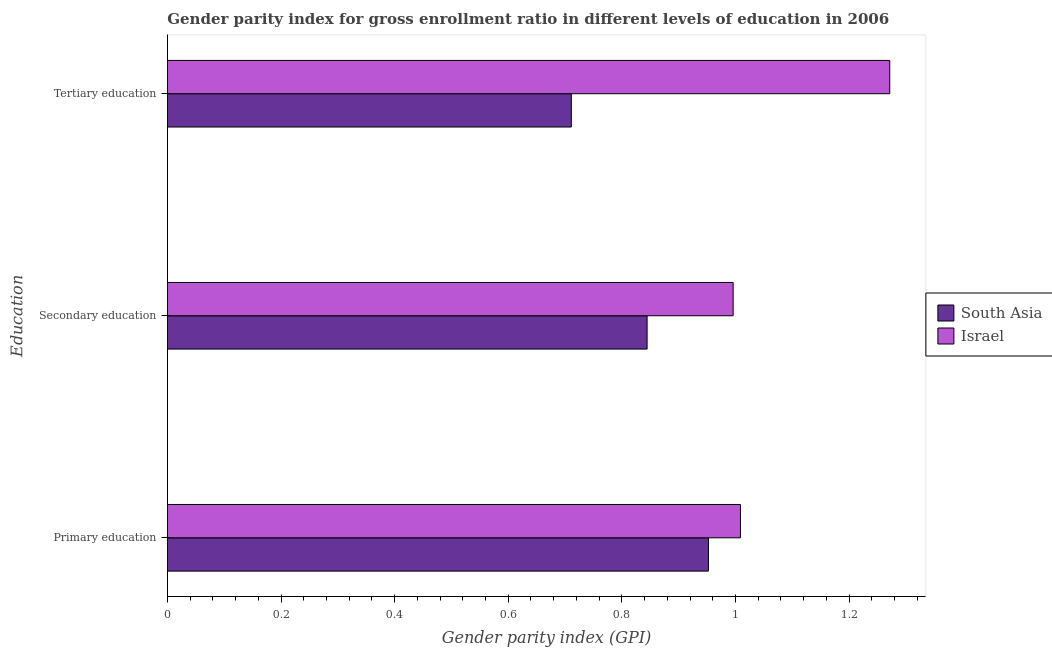How many groups of bars are there?
Your response must be concise. 3. What is the label of the 1st group of bars from the top?
Provide a short and direct response. Tertiary education. What is the gender parity index in secondary education in Israel?
Give a very brief answer. 1. Across all countries, what is the maximum gender parity index in tertiary education?
Keep it short and to the point. 1.27. Across all countries, what is the minimum gender parity index in secondary education?
Ensure brevity in your answer.  0.84. In which country was the gender parity index in primary education minimum?
Offer a terse response. South Asia. What is the total gender parity index in primary education in the graph?
Offer a terse response. 1.96. What is the difference between the gender parity index in tertiary education in Israel and that in South Asia?
Offer a very short reply. 0.56. What is the difference between the gender parity index in secondary education in Israel and the gender parity index in primary education in South Asia?
Give a very brief answer. 0.04. What is the average gender parity index in secondary education per country?
Provide a short and direct response. 0.92. What is the difference between the gender parity index in secondary education and gender parity index in primary education in South Asia?
Make the answer very short. -0.11. In how many countries, is the gender parity index in primary education greater than 1.2000000000000002 ?
Your answer should be compact. 0. What is the ratio of the gender parity index in secondary education in Israel to that in South Asia?
Your answer should be compact. 1.18. Is the gender parity index in primary education in Israel less than that in South Asia?
Keep it short and to the point. No. What is the difference between the highest and the second highest gender parity index in primary education?
Your answer should be very brief. 0.06. What is the difference between the highest and the lowest gender parity index in tertiary education?
Ensure brevity in your answer.  0.56. Is the sum of the gender parity index in tertiary education in Israel and South Asia greater than the maximum gender parity index in primary education across all countries?
Make the answer very short. Yes. What does the 2nd bar from the top in Secondary education represents?
Offer a very short reply. South Asia. What does the 2nd bar from the bottom in Primary education represents?
Provide a short and direct response. Israel. How many countries are there in the graph?
Offer a very short reply. 2. What is the difference between two consecutive major ticks on the X-axis?
Your response must be concise. 0.2. Does the graph contain any zero values?
Your answer should be compact. No. Does the graph contain grids?
Make the answer very short. No. Where does the legend appear in the graph?
Your response must be concise. Center right. How many legend labels are there?
Provide a succinct answer. 2. What is the title of the graph?
Keep it short and to the point. Gender parity index for gross enrollment ratio in different levels of education in 2006. Does "Ghana" appear as one of the legend labels in the graph?
Your response must be concise. No. What is the label or title of the X-axis?
Offer a very short reply. Gender parity index (GPI). What is the label or title of the Y-axis?
Make the answer very short. Education. What is the Gender parity index (GPI) in South Asia in Primary education?
Your answer should be compact. 0.95. What is the Gender parity index (GPI) in Israel in Primary education?
Your answer should be very brief. 1.01. What is the Gender parity index (GPI) in South Asia in Secondary education?
Provide a succinct answer. 0.84. What is the Gender parity index (GPI) of Israel in Secondary education?
Your response must be concise. 1. What is the Gender parity index (GPI) of South Asia in Tertiary education?
Your response must be concise. 0.71. What is the Gender parity index (GPI) in Israel in Tertiary education?
Offer a terse response. 1.27. Across all Education, what is the maximum Gender parity index (GPI) of South Asia?
Your response must be concise. 0.95. Across all Education, what is the maximum Gender parity index (GPI) in Israel?
Your answer should be compact. 1.27. Across all Education, what is the minimum Gender parity index (GPI) of South Asia?
Ensure brevity in your answer.  0.71. Across all Education, what is the minimum Gender parity index (GPI) of Israel?
Keep it short and to the point. 1. What is the total Gender parity index (GPI) in South Asia in the graph?
Your response must be concise. 2.51. What is the total Gender parity index (GPI) in Israel in the graph?
Your answer should be very brief. 3.28. What is the difference between the Gender parity index (GPI) of South Asia in Primary education and that in Secondary education?
Provide a short and direct response. 0.11. What is the difference between the Gender parity index (GPI) in Israel in Primary education and that in Secondary education?
Offer a terse response. 0.01. What is the difference between the Gender parity index (GPI) of South Asia in Primary education and that in Tertiary education?
Your answer should be very brief. 0.24. What is the difference between the Gender parity index (GPI) of Israel in Primary education and that in Tertiary education?
Provide a short and direct response. -0.26. What is the difference between the Gender parity index (GPI) of South Asia in Secondary education and that in Tertiary education?
Ensure brevity in your answer.  0.13. What is the difference between the Gender parity index (GPI) of Israel in Secondary education and that in Tertiary education?
Make the answer very short. -0.28. What is the difference between the Gender parity index (GPI) of South Asia in Primary education and the Gender parity index (GPI) of Israel in Secondary education?
Your answer should be compact. -0.04. What is the difference between the Gender parity index (GPI) of South Asia in Primary education and the Gender parity index (GPI) of Israel in Tertiary education?
Your answer should be very brief. -0.32. What is the difference between the Gender parity index (GPI) in South Asia in Secondary education and the Gender parity index (GPI) in Israel in Tertiary education?
Provide a short and direct response. -0.43. What is the average Gender parity index (GPI) in South Asia per Education?
Your answer should be compact. 0.84. What is the average Gender parity index (GPI) in Israel per Education?
Keep it short and to the point. 1.09. What is the difference between the Gender parity index (GPI) in South Asia and Gender parity index (GPI) in Israel in Primary education?
Your answer should be compact. -0.06. What is the difference between the Gender parity index (GPI) of South Asia and Gender parity index (GPI) of Israel in Secondary education?
Offer a very short reply. -0.15. What is the difference between the Gender parity index (GPI) of South Asia and Gender parity index (GPI) of Israel in Tertiary education?
Your response must be concise. -0.56. What is the ratio of the Gender parity index (GPI) in South Asia in Primary education to that in Secondary education?
Provide a succinct answer. 1.13. What is the ratio of the Gender parity index (GPI) in Israel in Primary education to that in Secondary education?
Your response must be concise. 1.01. What is the ratio of the Gender parity index (GPI) of South Asia in Primary education to that in Tertiary education?
Provide a succinct answer. 1.34. What is the ratio of the Gender parity index (GPI) in Israel in Primary education to that in Tertiary education?
Provide a short and direct response. 0.79. What is the ratio of the Gender parity index (GPI) in South Asia in Secondary education to that in Tertiary education?
Your response must be concise. 1.19. What is the ratio of the Gender parity index (GPI) in Israel in Secondary education to that in Tertiary education?
Give a very brief answer. 0.78. What is the difference between the highest and the second highest Gender parity index (GPI) of South Asia?
Your answer should be very brief. 0.11. What is the difference between the highest and the second highest Gender parity index (GPI) in Israel?
Keep it short and to the point. 0.26. What is the difference between the highest and the lowest Gender parity index (GPI) of South Asia?
Offer a terse response. 0.24. What is the difference between the highest and the lowest Gender parity index (GPI) in Israel?
Your response must be concise. 0.28. 